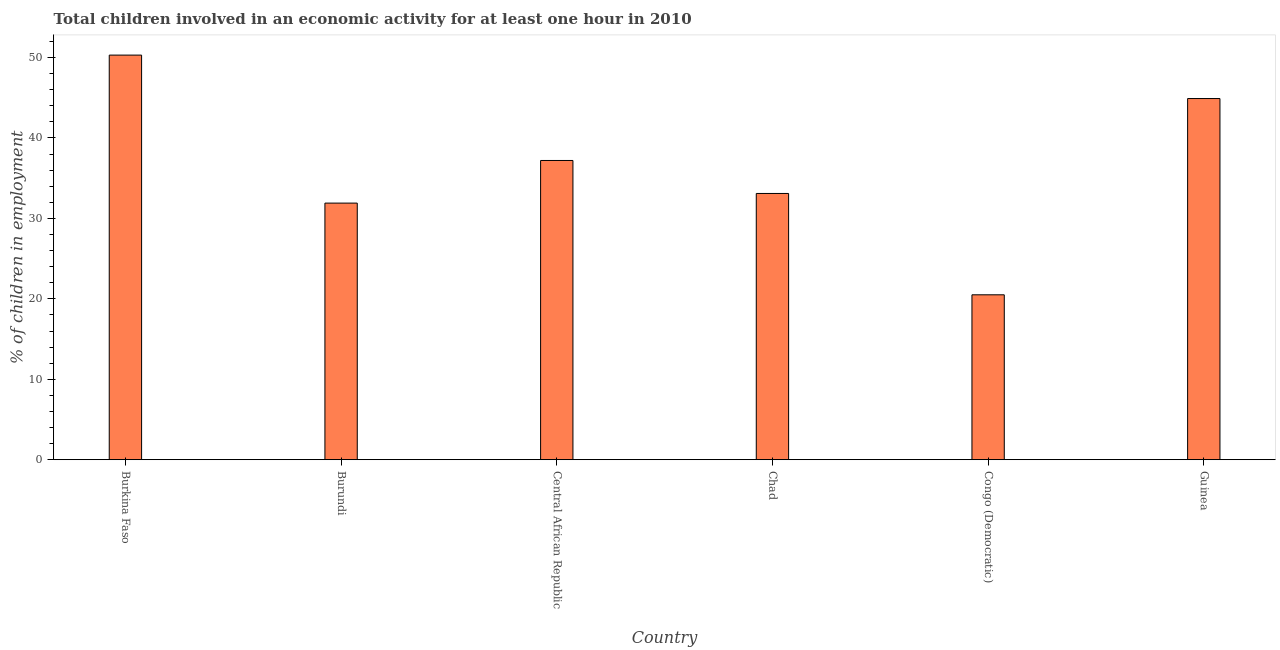Does the graph contain any zero values?
Give a very brief answer. No. Does the graph contain grids?
Your answer should be compact. No. What is the title of the graph?
Give a very brief answer. Total children involved in an economic activity for at least one hour in 2010. What is the label or title of the X-axis?
Your answer should be very brief. Country. What is the label or title of the Y-axis?
Provide a short and direct response. % of children in employment. What is the percentage of children in employment in Guinea?
Your answer should be very brief. 44.9. Across all countries, what is the maximum percentage of children in employment?
Your answer should be compact. 50.3. Across all countries, what is the minimum percentage of children in employment?
Your response must be concise. 20.5. In which country was the percentage of children in employment maximum?
Offer a terse response. Burkina Faso. In which country was the percentage of children in employment minimum?
Give a very brief answer. Congo (Democratic). What is the sum of the percentage of children in employment?
Your answer should be compact. 217.9. What is the difference between the percentage of children in employment in Central African Republic and Guinea?
Provide a short and direct response. -7.7. What is the average percentage of children in employment per country?
Your response must be concise. 36.32. What is the median percentage of children in employment?
Give a very brief answer. 35.15. In how many countries, is the percentage of children in employment greater than 22 %?
Offer a terse response. 5. What is the ratio of the percentage of children in employment in Congo (Democratic) to that in Guinea?
Give a very brief answer. 0.46. Is the difference between the percentage of children in employment in Burundi and Guinea greater than the difference between any two countries?
Make the answer very short. No. What is the difference between the highest and the lowest percentage of children in employment?
Provide a succinct answer. 29.8. In how many countries, is the percentage of children in employment greater than the average percentage of children in employment taken over all countries?
Offer a terse response. 3. How many bars are there?
Ensure brevity in your answer.  6. Are the values on the major ticks of Y-axis written in scientific E-notation?
Provide a short and direct response. No. What is the % of children in employment in Burkina Faso?
Ensure brevity in your answer.  50.3. What is the % of children in employment of Burundi?
Your response must be concise. 31.9. What is the % of children in employment in Central African Republic?
Keep it short and to the point. 37.2. What is the % of children in employment of Chad?
Ensure brevity in your answer.  33.1. What is the % of children in employment in Congo (Democratic)?
Provide a succinct answer. 20.5. What is the % of children in employment of Guinea?
Your answer should be very brief. 44.9. What is the difference between the % of children in employment in Burkina Faso and Burundi?
Ensure brevity in your answer.  18.4. What is the difference between the % of children in employment in Burkina Faso and Congo (Democratic)?
Ensure brevity in your answer.  29.8. What is the difference between the % of children in employment in Burundi and Chad?
Keep it short and to the point. -1.2. What is the difference between the % of children in employment in Burundi and Congo (Democratic)?
Offer a very short reply. 11.4. What is the difference between the % of children in employment in Burundi and Guinea?
Your answer should be very brief. -13. What is the difference between the % of children in employment in Central African Republic and Congo (Democratic)?
Offer a terse response. 16.7. What is the difference between the % of children in employment in Chad and Congo (Democratic)?
Keep it short and to the point. 12.6. What is the difference between the % of children in employment in Chad and Guinea?
Offer a terse response. -11.8. What is the difference between the % of children in employment in Congo (Democratic) and Guinea?
Provide a succinct answer. -24.4. What is the ratio of the % of children in employment in Burkina Faso to that in Burundi?
Give a very brief answer. 1.58. What is the ratio of the % of children in employment in Burkina Faso to that in Central African Republic?
Provide a short and direct response. 1.35. What is the ratio of the % of children in employment in Burkina Faso to that in Chad?
Give a very brief answer. 1.52. What is the ratio of the % of children in employment in Burkina Faso to that in Congo (Democratic)?
Offer a terse response. 2.45. What is the ratio of the % of children in employment in Burkina Faso to that in Guinea?
Give a very brief answer. 1.12. What is the ratio of the % of children in employment in Burundi to that in Central African Republic?
Keep it short and to the point. 0.86. What is the ratio of the % of children in employment in Burundi to that in Congo (Democratic)?
Ensure brevity in your answer.  1.56. What is the ratio of the % of children in employment in Burundi to that in Guinea?
Keep it short and to the point. 0.71. What is the ratio of the % of children in employment in Central African Republic to that in Chad?
Offer a terse response. 1.12. What is the ratio of the % of children in employment in Central African Republic to that in Congo (Democratic)?
Offer a terse response. 1.81. What is the ratio of the % of children in employment in Central African Republic to that in Guinea?
Offer a very short reply. 0.83. What is the ratio of the % of children in employment in Chad to that in Congo (Democratic)?
Your answer should be very brief. 1.61. What is the ratio of the % of children in employment in Chad to that in Guinea?
Keep it short and to the point. 0.74. What is the ratio of the % of children in employment in Congo (Democratic) to that in Guinea?
Your answer should be compact. 0.46. 